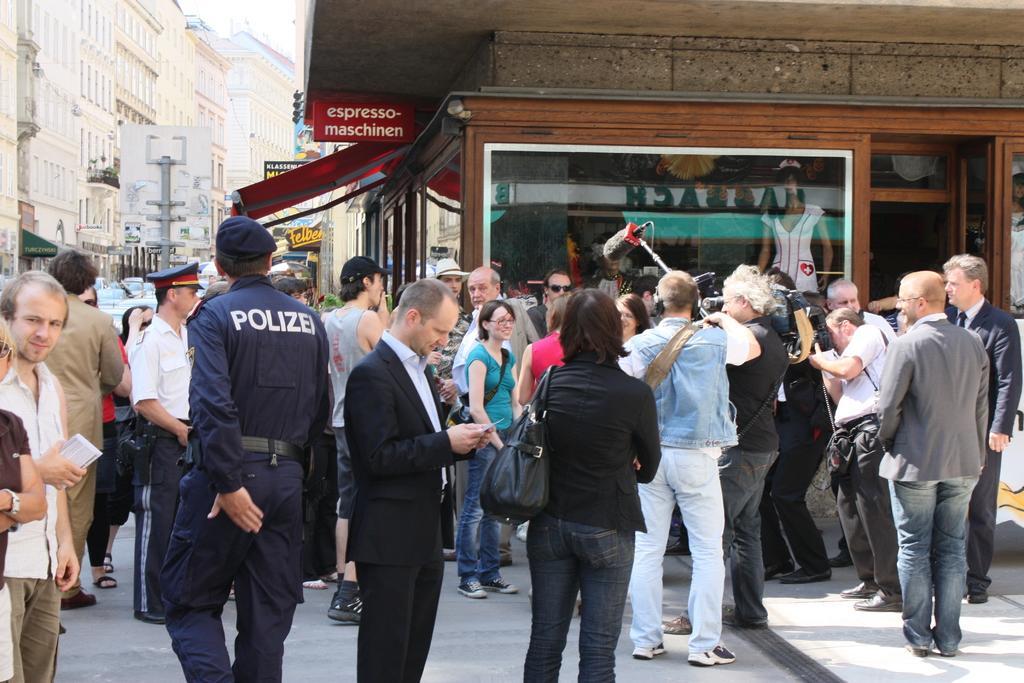Describe this image in one or two sentences. In the image I can see some people, among them some people are holding somethings and around there are some buildings to which there are some boards and also I can see some poles. 